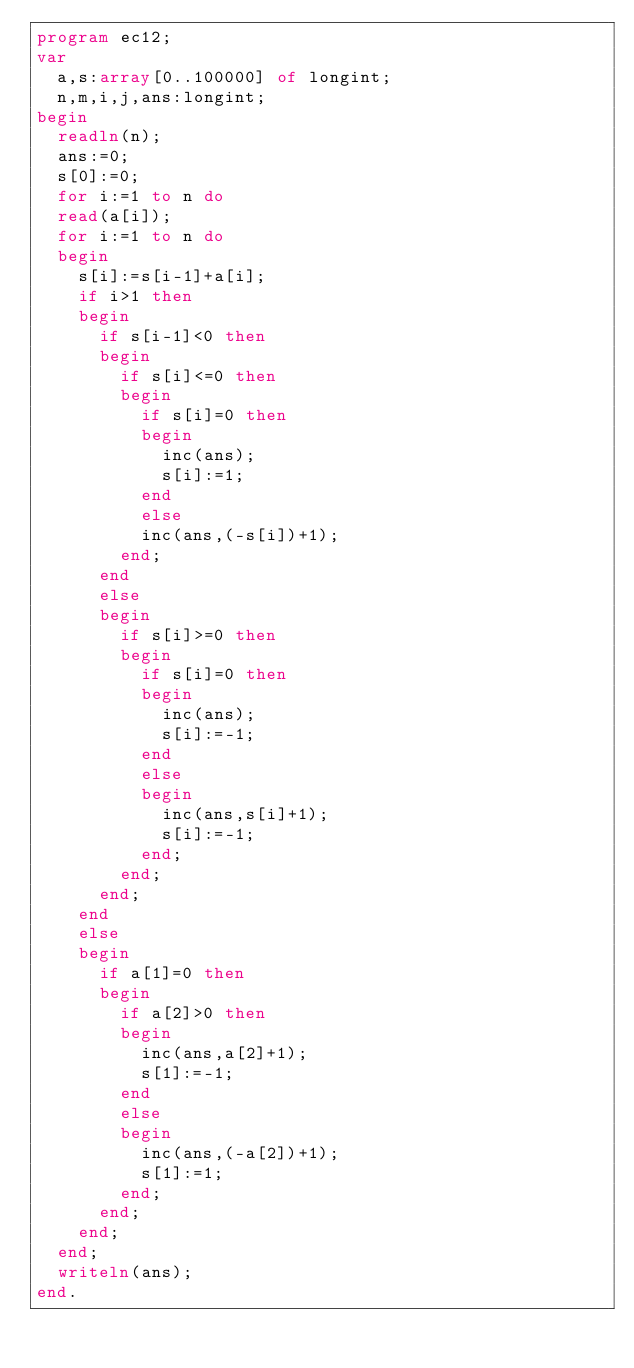<code> <loc_0><loc_0><loc_500><loc_500><_Pascal_>program ec12;
var 
	a,s:array[0..100000] of longint;
	n,m,i,j,ans:longint;
begin 	
	readln(n);
	ans:=0;
	s[0]:=0;
	for i:=1 to n do
	read(a[i]);
	for i:=1 to n do 
	begin 
		s[i]:=s[i-1]+a[i];
		if i>1 then 
		begin 
			if s[i-1]<0 then 
			begin	
				if s[i]<=0 then 
				begin
					if s[i]=0 then 
					begin 
						inc(ans);
						s[i]:=1;
					end
					else
					inc(ans,(-s[i])+1);
				end;
			end
			else
			begin 
				if s[i]>=0 then 
				begin 
					if s[i]=0 then 
					begin 
						inc(ans);
						s[i]:=-1;
					end
					else
					begin 
						inc(ans,s[i]+1);
						s[i]:=-1;
					end;
				end;
			end;
		end
		else
		begin 
			if a[1]=0 then 
			begin 
				if a[2]>0 then 
				begin 	
					inc(ans,a[2]+1);
					s[1]:=-1;
				end
				else
				begin 
					inc(ans,(-a[2])+1);
					s[1]:=1;
				end;
			end;
		end;
	end;
	writeln(ans);
end. </code> 